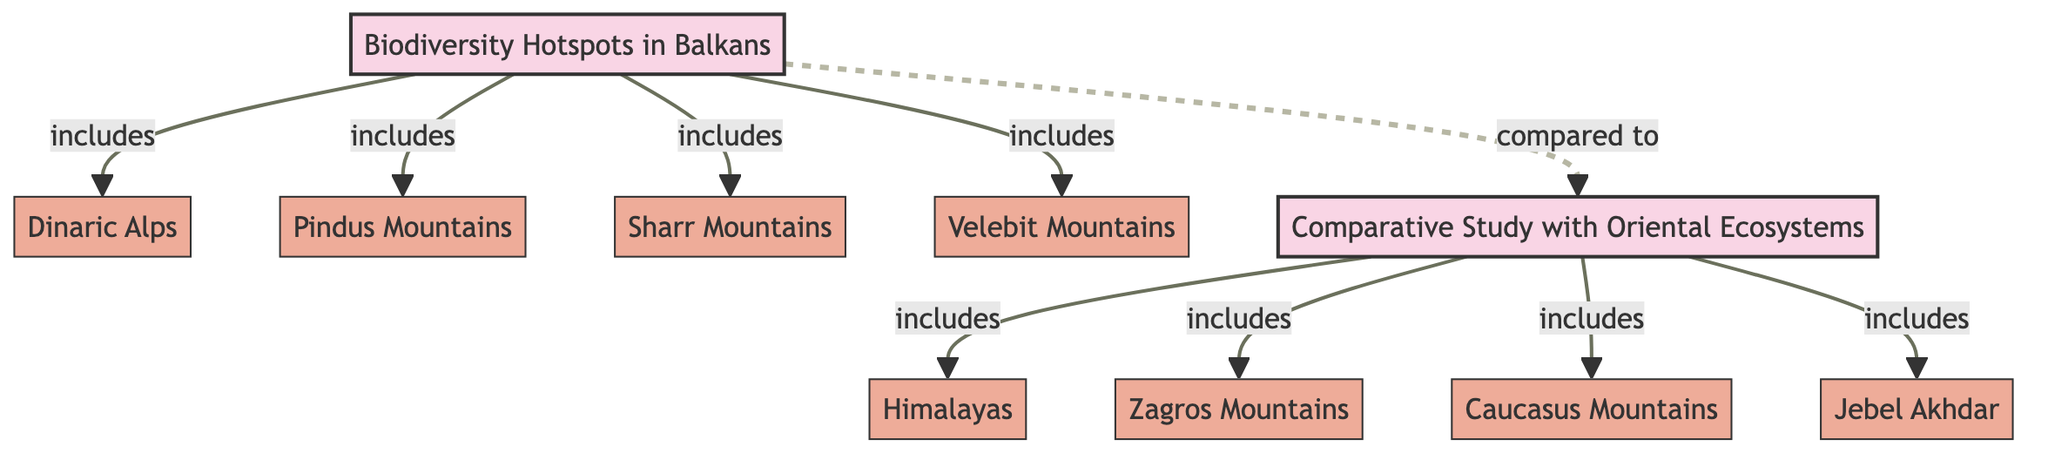What are the biodiversity hotspots mentioned in the diagram? The diagram lists the biodiversity hotspots in the Balkans, which include the Dinaric Alps, Pindus Mountains, Sharr Mountains, and Velebit Mountains.
Answer: Dinaric Alps, Pindus Mountains, Sharr Mountains, Velebit Mountains How many biodiversity hotspots are included in the Balkans section? Counting the nodes connected to the "Biodiversity Hotspots in Balkans" node shows four hotspots: Dinaric Alps, Pindus Mountains, Sharr Mountains, and Velebit Mountains.
Answer: 4 Which ecosystem is compared to the Balkans? The diagram indicates a comparative study with "Oriental Ecosystems," which is a broader term encompassing specific ecosystems.
Answer: Oriental Ecosystems List two ecosystems included in the Oriental Ecosystems section. The diagram includes the Himalayas, Zagros Mountains, Caucasus Mountains, and Jebel Akhdar in the Oriental Ecosystems section. Two examples are Himalayas and Zagros Mountains.
Answer: Himalayas, Zagros Mountains What is the relationship between the Balkan hotspots and the Oriental ecosystems as depicted in this diagram? The diagram uses a dashed line to indicate a comparative relationship between the "Biodiversity Hotspots in Balkans" and "Comparative Study with Oriental Ecosystems." This signifies that while they are separate entities, they have been studied in relation to one another.
Answer: Compared to Which ecosystem has a direct 'includes' relationship with the "Comparative Study with Oriental Ecosystems"? The diagram illustrates that the Himalayas, Zagros Mountains, Caucasus Mountains, and Jebel Akhdar are included ecosystems in the "Comparative Study with Oriental Ecosystems." Each of these ecosystems has a direct 'includes' relationship with the topic.
Answer: Himalayas How many ecosystems are included in the "Comparative Study with Oriental Ecosystems"? There are four ecosystems included in the "Comparative Study with Oriental Ecosystems," which are specified in the diagram: Himalayas, Zagros Mountains, Caucasus Mountains, and Jebel Akhdar.
Answer: 4 What is the visual representation style for the topic nodes in the diagram? The topic nodes, such as "Biodiversity Hotspots in Balkans" and "Comparative Study with Oriental Ecosystems," are styled with a fill color of light pink and a thick stroke, denoting their significance in the diagram.
Answer: Fill color of light pink, thick stroke Which mountain range is NOT included as a biodiversity hotspot in the Balkans? By reviewing the hotspots listed, it's clear that among the various ecosystems included, no mention of a specific mountain range such as the "Caucasus Mountains," points to its exclusion.
Answer: Caucasus Mountains 